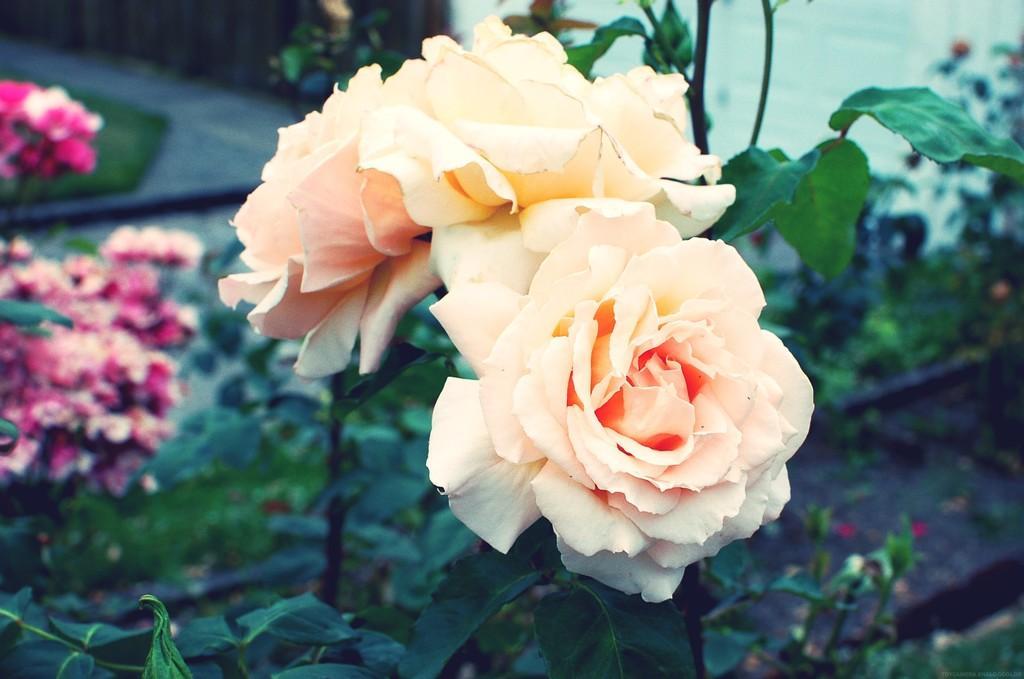Please provide a concise description of this image. In this picture we can see few flowers and plants. 